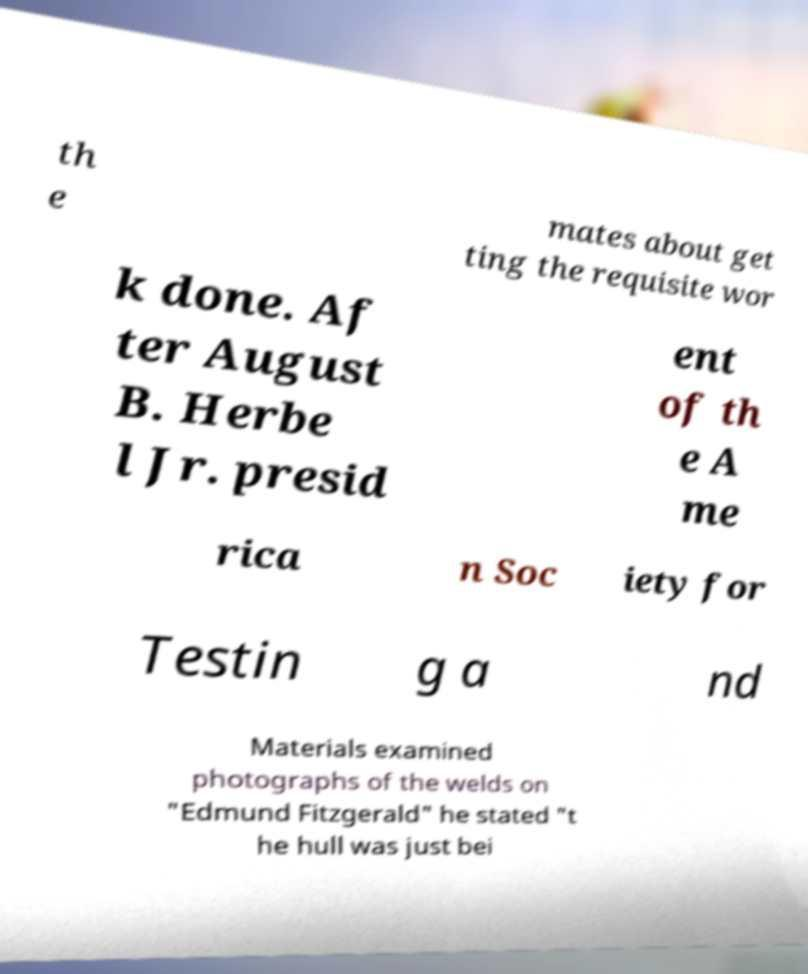For documentation purposes, I need the text within this image transcribed. Could you provide that? th e mates about get ting the requisite wor k done. Af ter August B. Herbe l Jr. presid ent of th e A me rica n Soc iety for Testin g a nd Materials examined photographs of the welds on "Edmund Fitzgerald" he stated "t he hull was just bei 